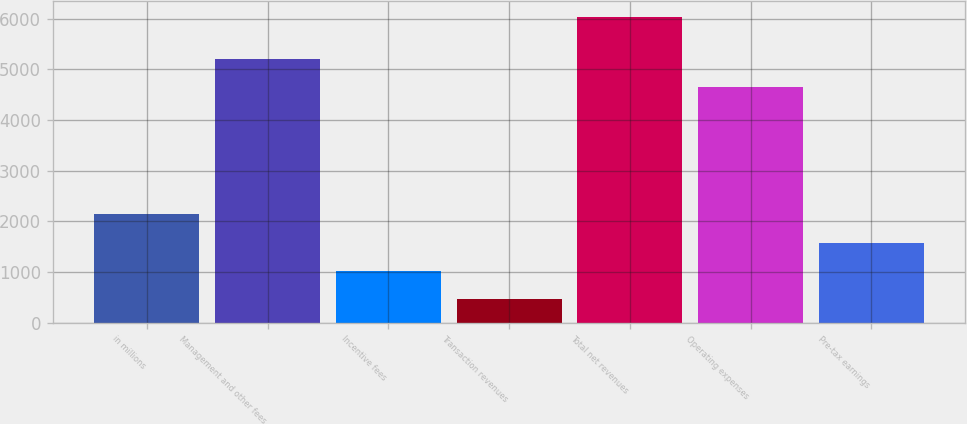<chart> <loc_0><loc_0><loc_500><loc_500><bar_chart><fcel>in millions<fcel>Management and other fees<fcel>Incentive fees<fcel>Transaction revenues<fcel>Total net revenues<fcel>Operating expenses<fcel>Pre-tax earnings<nl><fcel>2138.8<fcel>5204.6<fcel>1023.6<fcel>466<fcel>6042<fcel>4647<fcel>1581.2<nl></chart> 